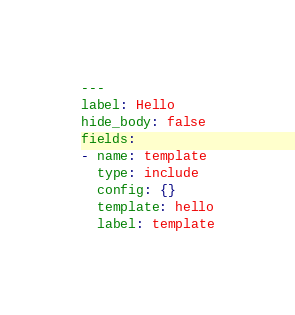Convert code to text. <code><loc_0><loc_0><loc_500><loc_500><_YAML_>---
label: Hello
hide_body: false
fields:
- name: template
  type: include
  config: {}
  template: hello
  label: template
</code> 